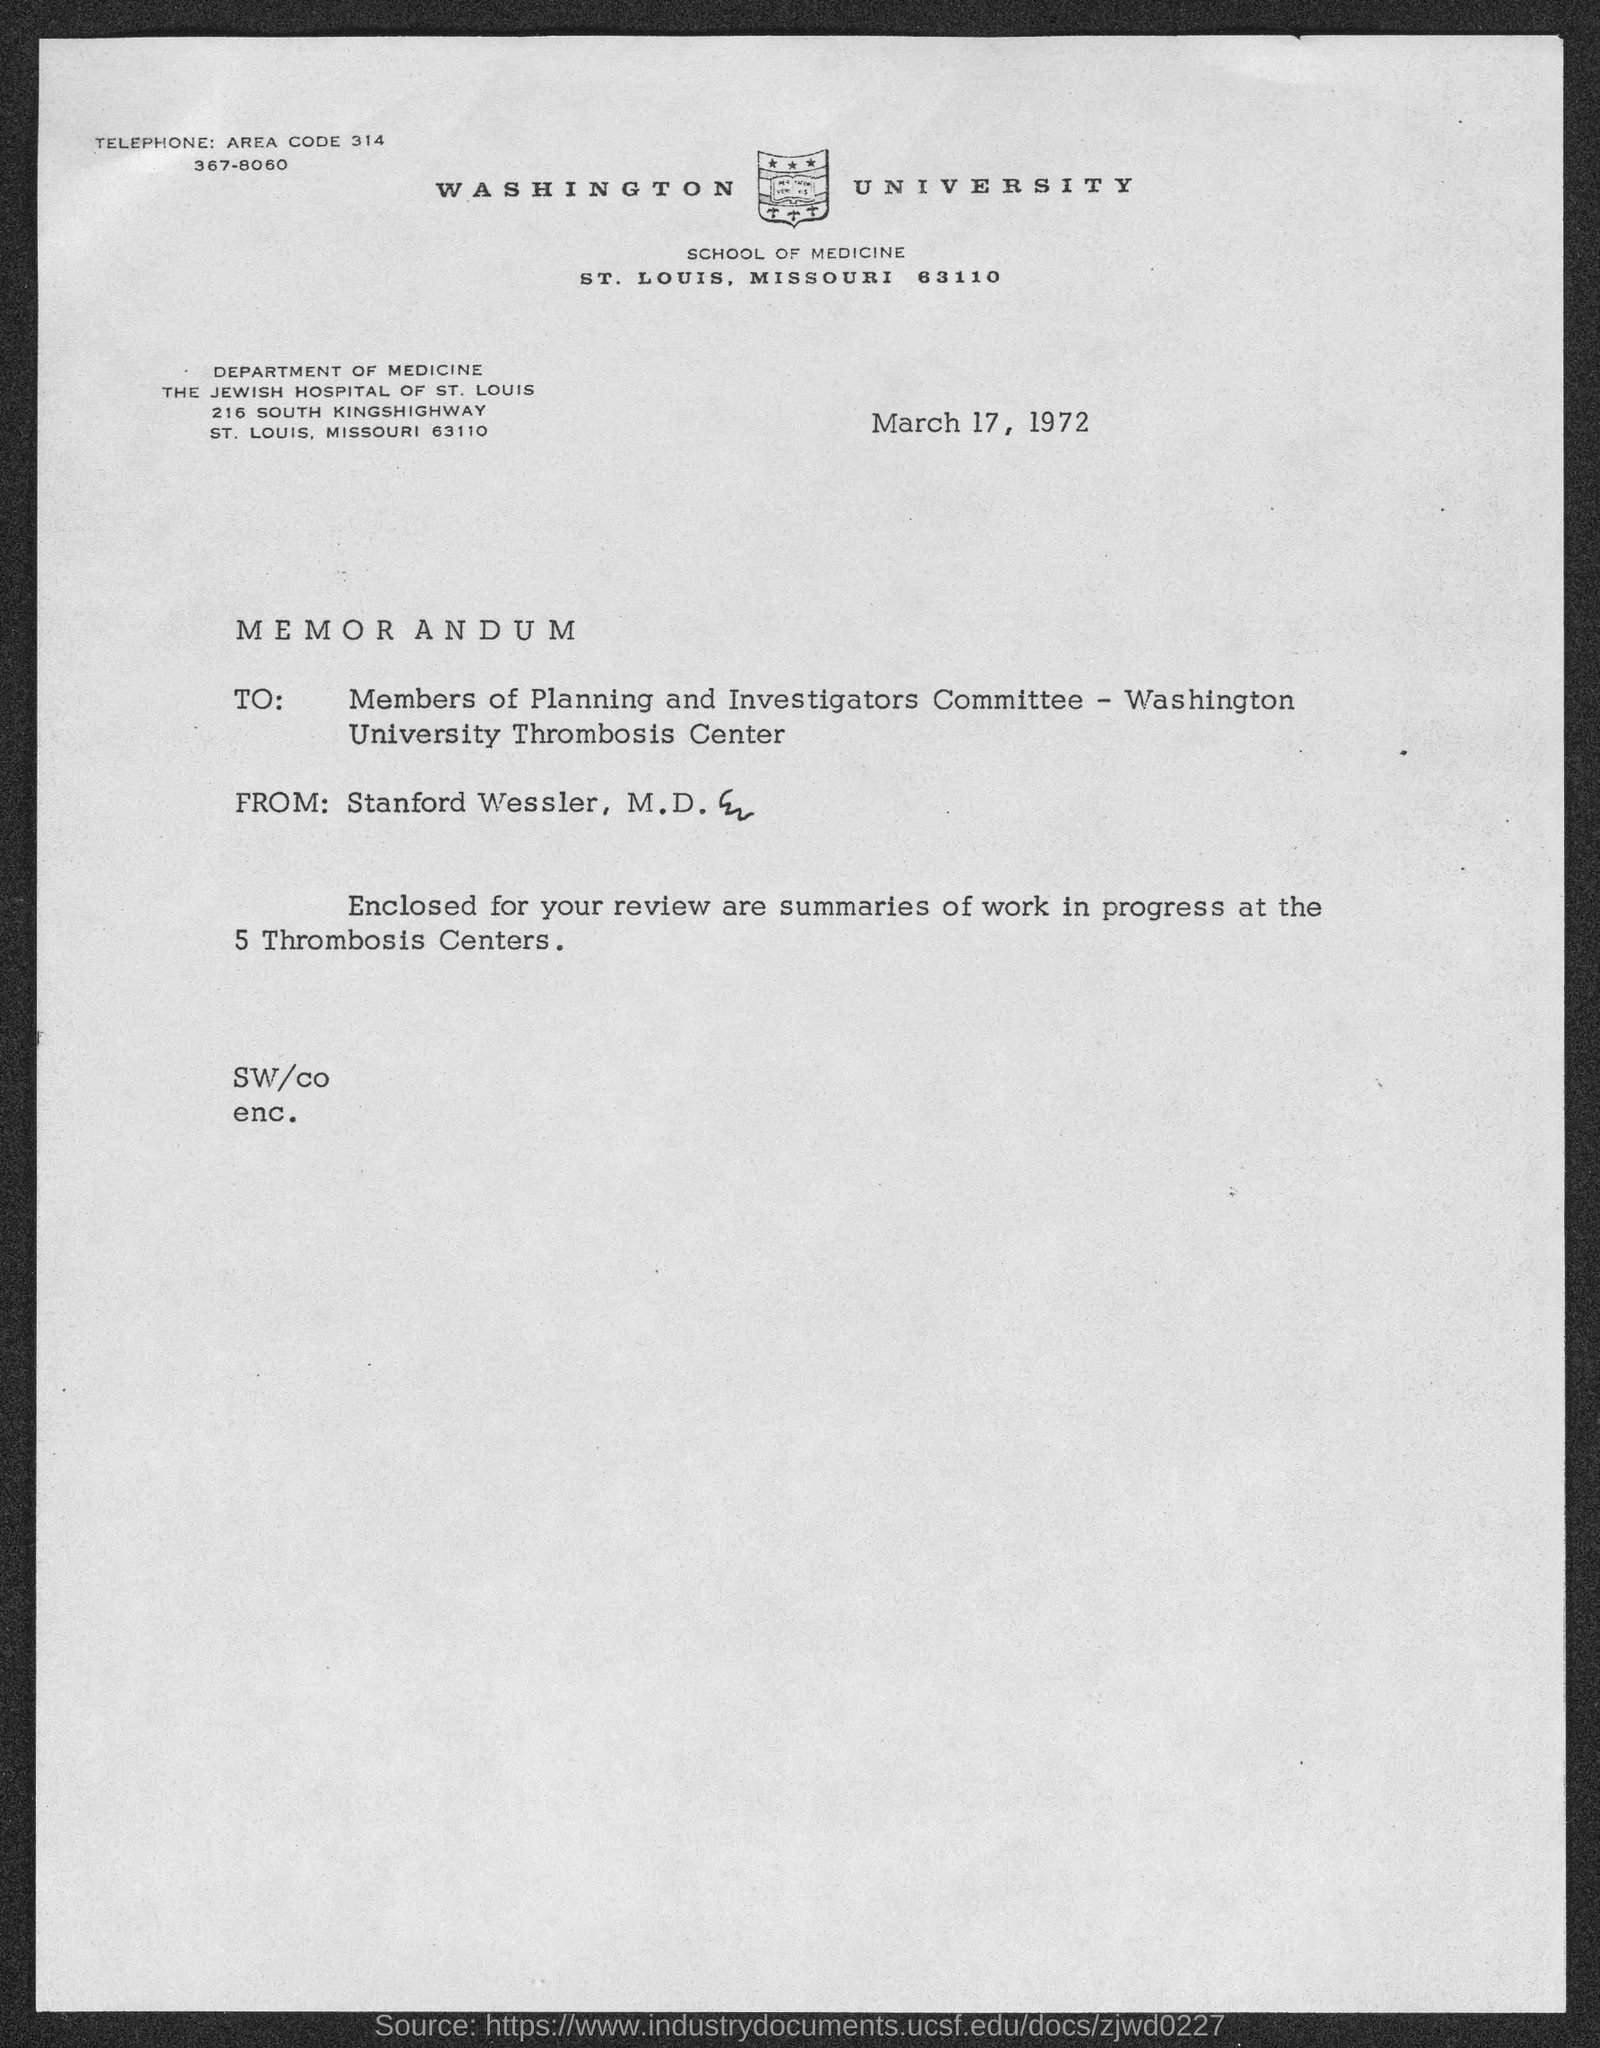In which county is washington university  located?
Keep it short and to the point. St. Louis. What is the street address of the jewish hospital of st. louis ?
Your answer should be compact. 216 South Kingshighway. What is the area code ?
Ensure brevity in your answer.  314. What is the telephone number of washington university ?
Your answer should be very brief. 367-8060. When is the memorandum dated?
Ensure brevity in your answer.  March 17, 1972. 